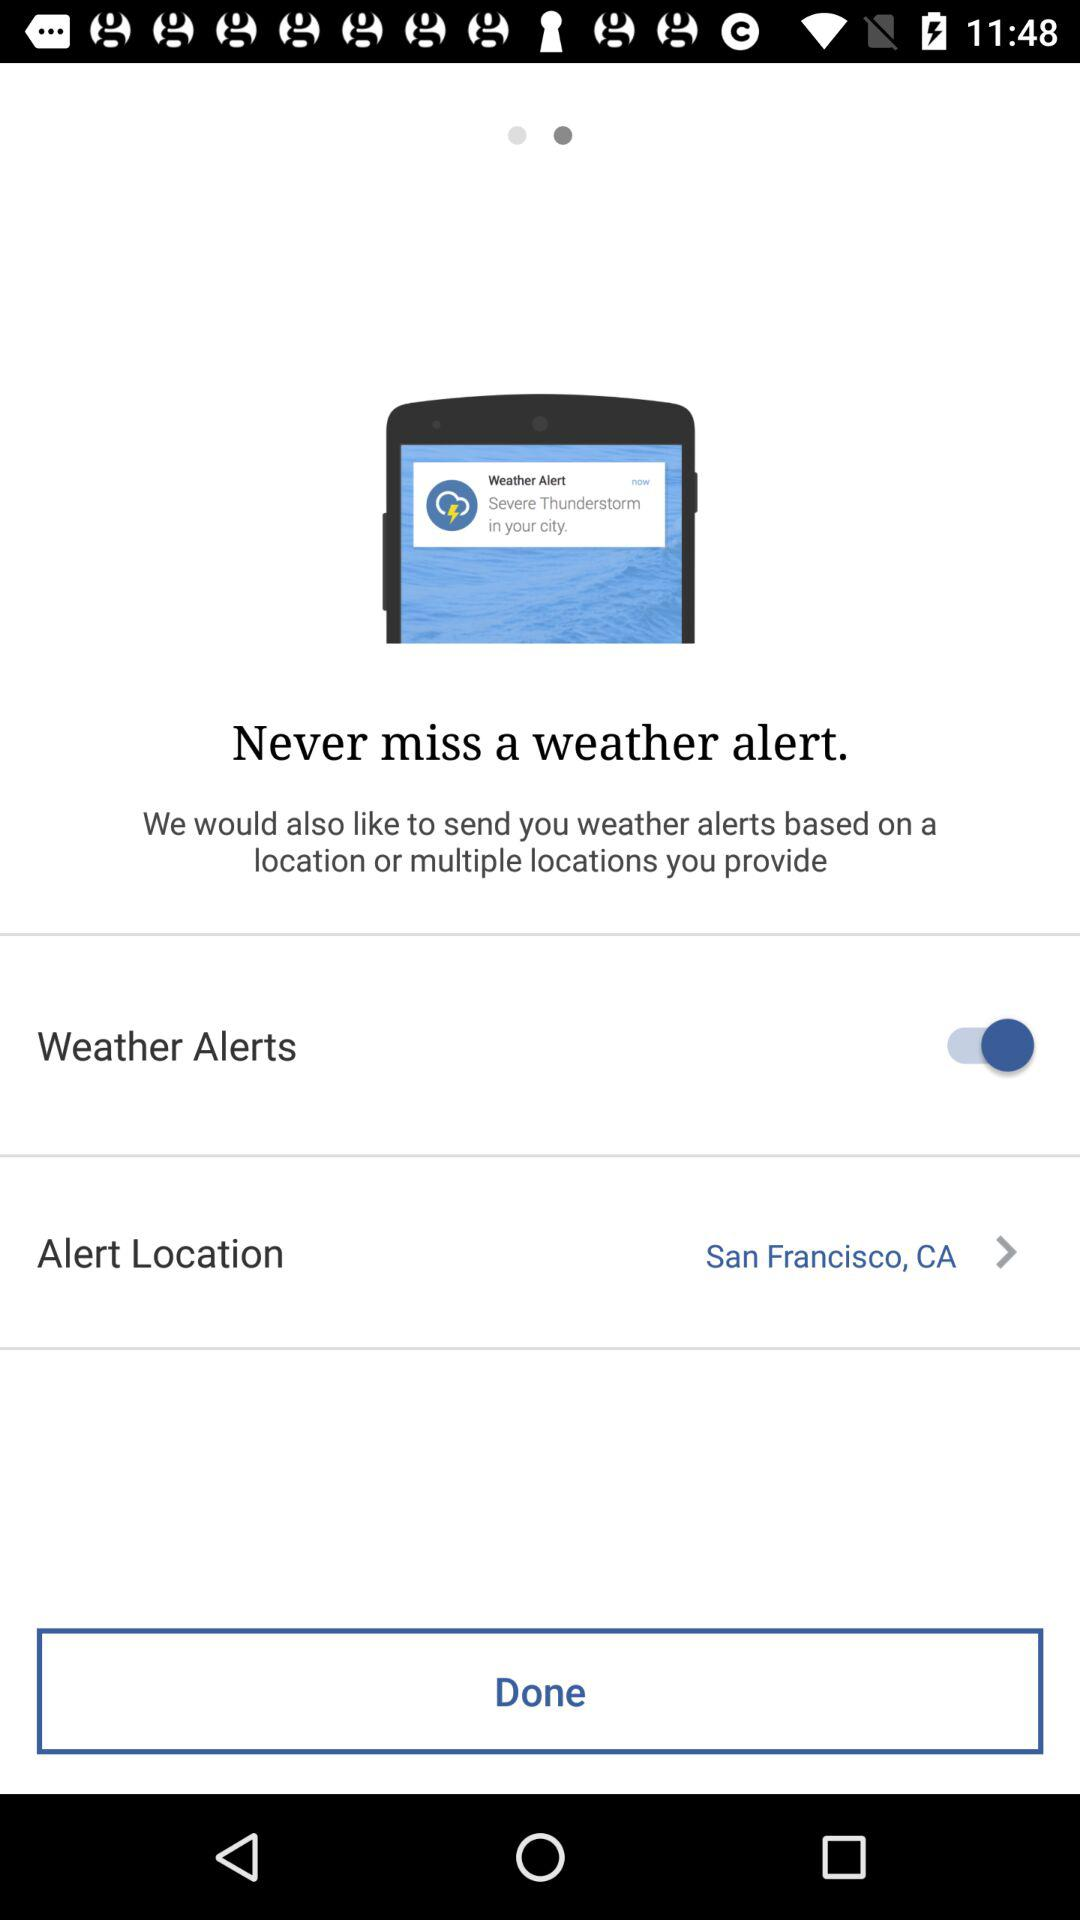What is an alert location? The alert location is San Francisco, CA. 